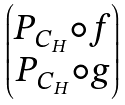Convert formula to latex. <formula><loc_0><loc_0><loc_500><loc_500>\begin{pmatrix} P _ { C _ { H } } \circ f \\ P _ { C _ { H } } \circ g \end{pmatrix}</formula> 